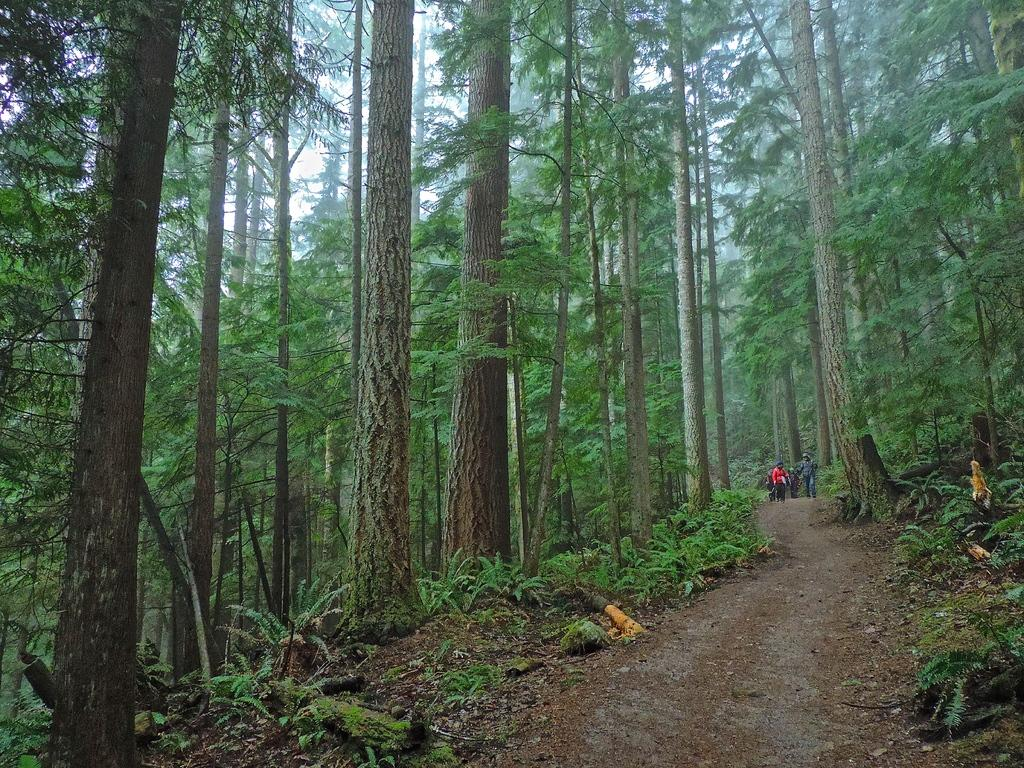How many people are in the image? There is a group of people in the image. What are the people in the image doing? The people are walking. What type of natural environment can be seen in the image? There are trees and plants in the image. What is visible at the top of the image? The sky is visible at the top of the image. What is visible at the bottom of the image? The ground is visible at the bottom of the image. What news is being offered to the people in the image? There is no news being offered to the people in the image; they are simply walking. What type of grass can be seen in the image? There is no grass visible in the image; it features trees and plants, but not grass specifically. 